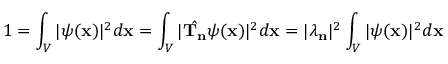<formula> <loc_0><loc_0><loc_500><loc_500>1 = \int _ { V } | \psi ( x ) | ^ { 2 } d x = \int _ { V } | { \hat { T _ { n } } } \psi ( x ) | ^ { 2 } d x = | \lambda _ { n } | ^ { 2 } \int _ { V } | \psi ( x ) | ^ { 2 } d x</formula> 